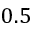Convert formula to latex. <formula><loc_0><loc_0><loc_500><loc_500>0 . 5</formula> 